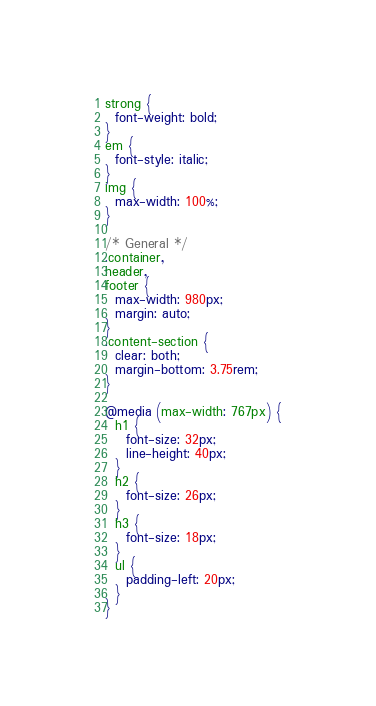Convert code to text. <code><loc_0><loc_0><loc_500><loc_500><_CSS_>strong {
  font-weight: bold;
}
em {
  font-style: italic;
}
img {
  max-width: 100%;
}

/* General */
.container,
header,
footer {
  max-width: 980px;
  margin: auto;
}
.content-section {
  clear: both;
  margin-bottom: 3.75rem;
}

@media (max-width: 767px) {
  h1 {
    font-size: 32px;
    line-height: 40px;
  }
  h2 {
    font-size: 26px;
  }
  h3 {
    font-size: 18px;
  }
  ul {
    padding-left: 20px;
  }
}</code> 